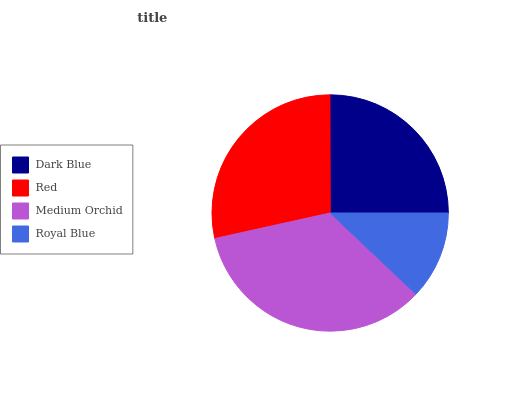Is Royal Blue the minimum?
Answer yes or no. Yes. Is Medium Orchid the maximum?
Answer yes or no. Yes. Is Red the minimum?
Answer yes or no. No. Is Red the maximum?
Answer yes or no. No. Is Red greater than Dark Blue?
Answer yes or no. Yes. Is Dark Blue less than Red?
Answer yes or no. Yes. Is Dark Blue greater than Red?
Answer yes or no. No. Is Red less than Dark Blue?
Answer yes or no. No. Is Red the high median?
Answer yes or no. Yes. Is Dark Blue the low median?
Answer yes or no. Yes. Is Medium Orchid the high median?
Answer yes or no. No. Is Royal Blue the low median?
Answer yes or no. No. 